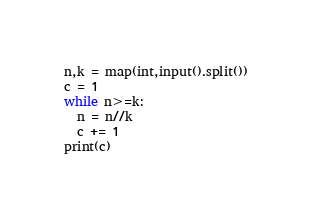Convert code to text. <code><loc_0><loc_0><loc_500><loc_500><_Python_>n,k = map(int,input().split())
c = 1
while n>=k:
  n = n//k
  c += 1
print(c)</code> 